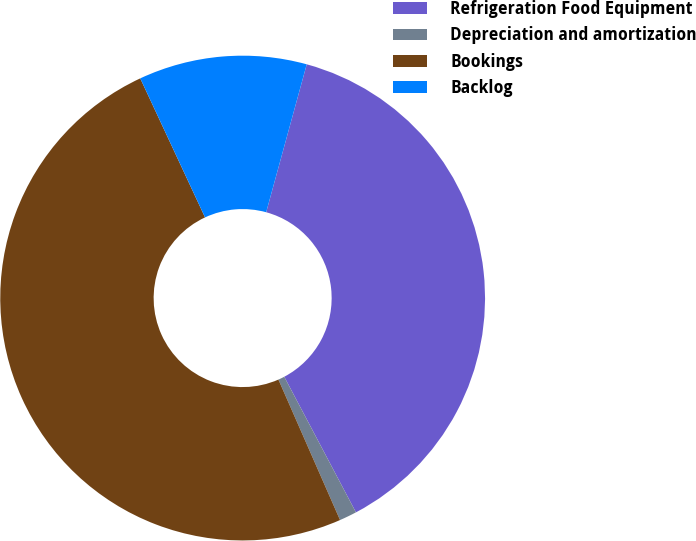Convert chart. <chart><loc_0><loc_0><loc_500><loc_500><pie_chart><fcel>Refrigeration Food Equipment<fcel>Depreciation and amortization<fcel>Bookings<fcel>Backlog<nl><fcel>38.0%<fcel>1.16%<fcel>49.64%<fcel>11.2%<nl></chart> 